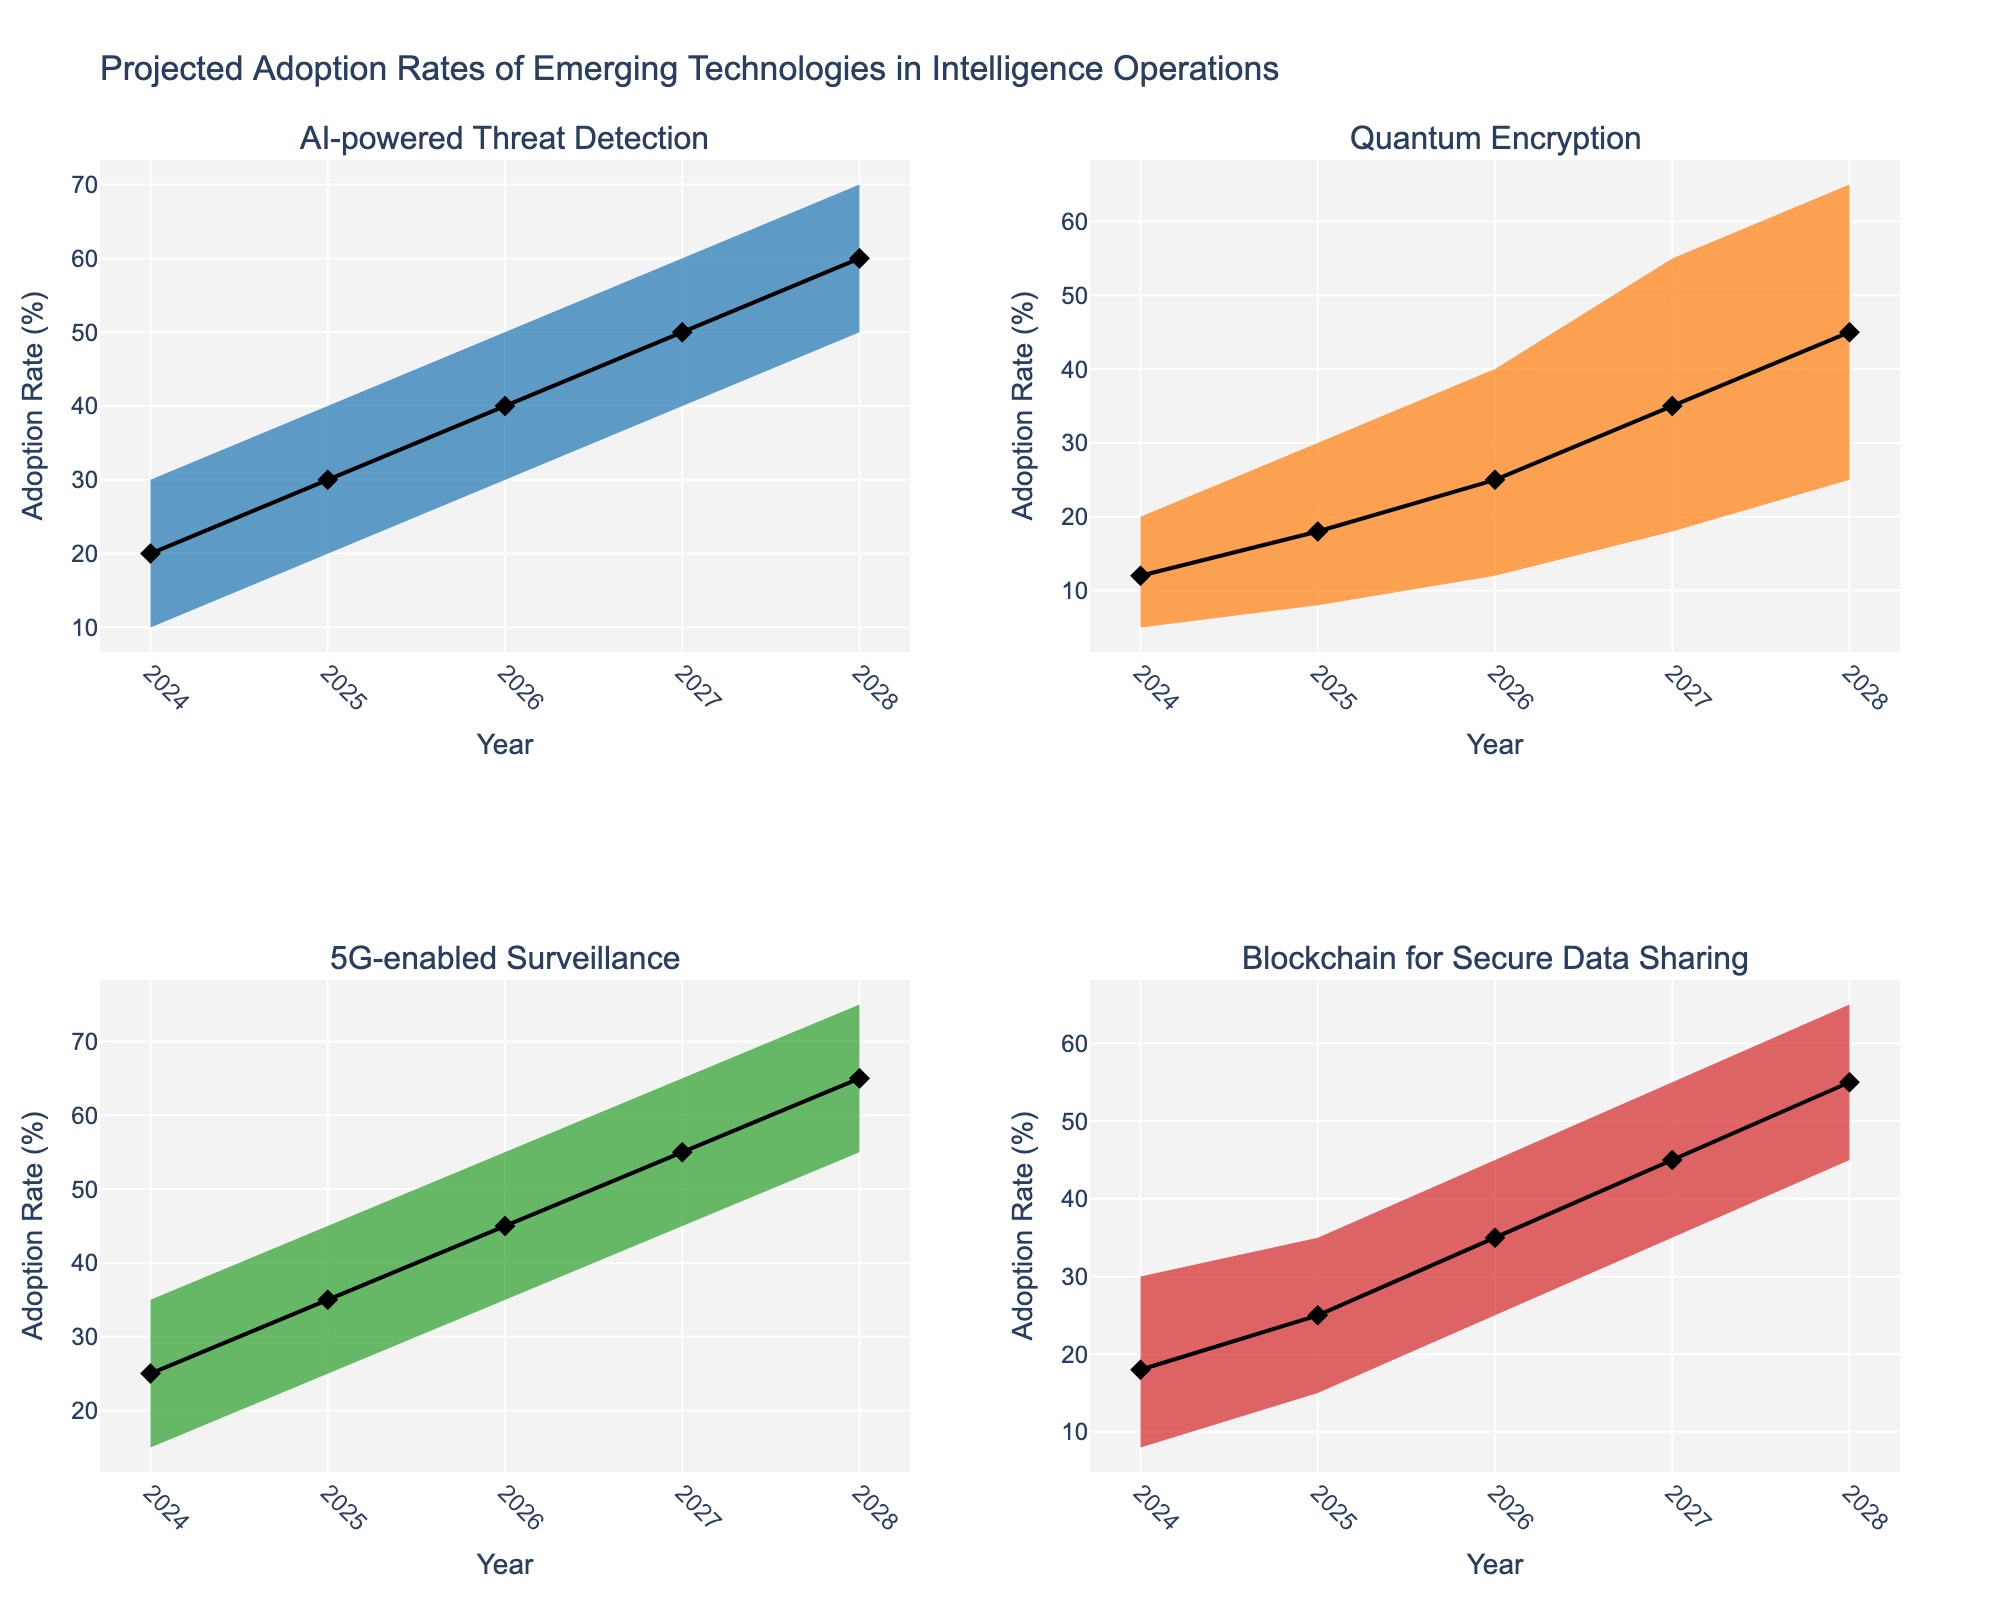What's the title of the figure? The title is located at the top center of the figure. It's explicitly mentioned in the code as "Projected Adoption Rates of Emerging Technologies in Intelligence Operations."
Answer: Projected Adoption Rates of Emerging Technologies in Intelligence Operations Which technology is projected to have the highest median adoption rate in 2026? The median adoption rate for each technology is represented by a diamond marker on the line plot within each subplot. By focusing on the year 2026, we can compare the median values. AI-powered Threat Detection has the highest median at 40%.
Answer: AI-powered Threat Detection What are the colors of the confidence interval ranges for the technologies? Each subplot has a distinct color for the confidence interval range. From the code, the order of technologies and their respective colors are: AI-powered Threat Detection (blue), Quantum Encryption (orange), 5G-enabled Surveillance (green), and Blockchain for Secure Data Sharing (red).
Answer: Blue, Orange, Green, Red Which technology shows the greatest increase in its median adoption rate from 2024 to 2028? We'll look at the median values for each technology in 2024 and 2028, then calculate the difference. AI-powered Threat Detection increases from 20% to 60%, showing the greatest increase of 40%.
Answer: AI-powered Threat Detection In 2027, how does the upper quartile adoption rate of Blockchain for Secure Data Sharing compare to Quantum Encryption? The upper quartile adoption rates are represented by the top of the darker shaded areas closer to the upper bound. In 2027, Blockchain for Secure Data Sharing has an upper quartile of 50%, while Quantum Encryption has 45%.
Answer: Higher What is the projected adoption range (High CI and Low CI) for 5G-enabled Surveillance in 2025? The range between the High CI and Low CI values represents the uncertainty span. In 2025, 5G-enabled Surveillance has a High CI of 45% and a Low CI of 25%, so the range is from 25% to 45%.
Answer: 25% to 45% Which year shows the least disparity between the technologies in terms of median adoption rates? By visually comparing the distances between the median markers (diamonds) for each year, we observe that the median values are closest in 2024, where they range more narrowly compared to other years.
Answer: 2024 What is the predicted confidence interval for Quantum Encryption in 2028? The confidence interval is shown shaded between the Low CI and High CI lines. For 2028, Quantum Encryption's range is from a Low CI of 25% to a High CI of 65%.
Answer: 25% to 65% Are the adoption rates for AI-powered Threat Detection and 5G-enabled Surveillance projected to follow similar trends? Both technologies start with lower adoption rates in earlier years and increase significantly over time. By 2028, they converge around similar median values and high projections, indicating similar upward trends.
Answer: Yes How do the lower quartiles of AI-powered Threat Detection and Blockchain for Secure Data Sharing compare in 2025? The lower quartile values can be found by examining the lower bound of the darker mid-shaded area. In 2025, AI-powered Threat Detection has a lower quartile of 25%, while Blockchain for Secure Data Sharing has 20%. Hence, AI-powered Threat Detection’s lower quartile is higher.
Answer: AI-powered Threat Detection’s is higher 